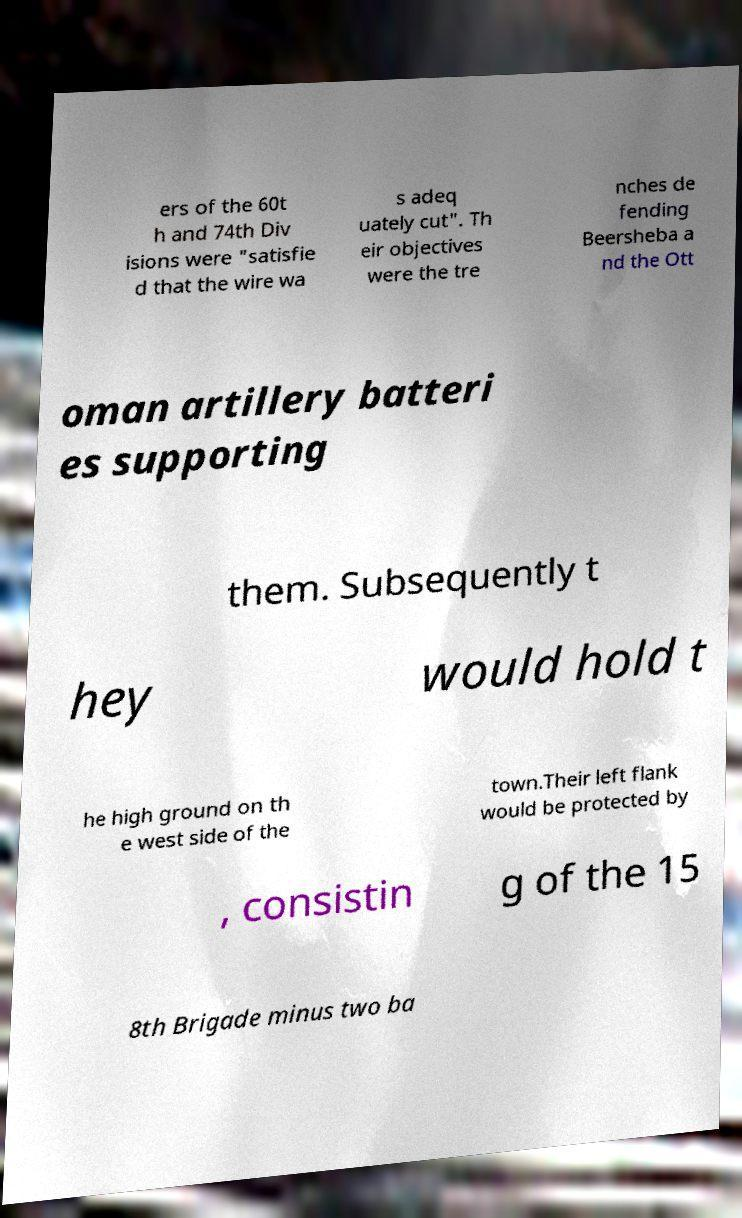There's text embedded in this image that I need extracted. Can you transcribe it verbatim? ers of the 60t h and 74th Div isions were "satisfie d that the wire wa s adeq uately cut". Th eir objectives were the tre nches de fending Beersheba a nd the Ott oman artillery batteri es supporting them. Subsequently t hey would hold t he high ground on th e west side of the town.Their left flank would be protected by , consistin g of the 15 8th Brigade minus two ba 